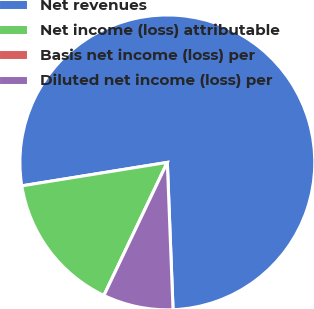Convert chart to OTSL. <chart><loc_0><loc_0><loc_500><loc_500><pie_chart><fcel>Net revenues<fcel>Net income (loss) attributable<fcel>Basis net income (loss) per<fcel>Diluted net income (loss) per<nl><fcel>76.92%<fcel>15.38%<fcel>0.0%<fcel>7.69%<nl></chart> 